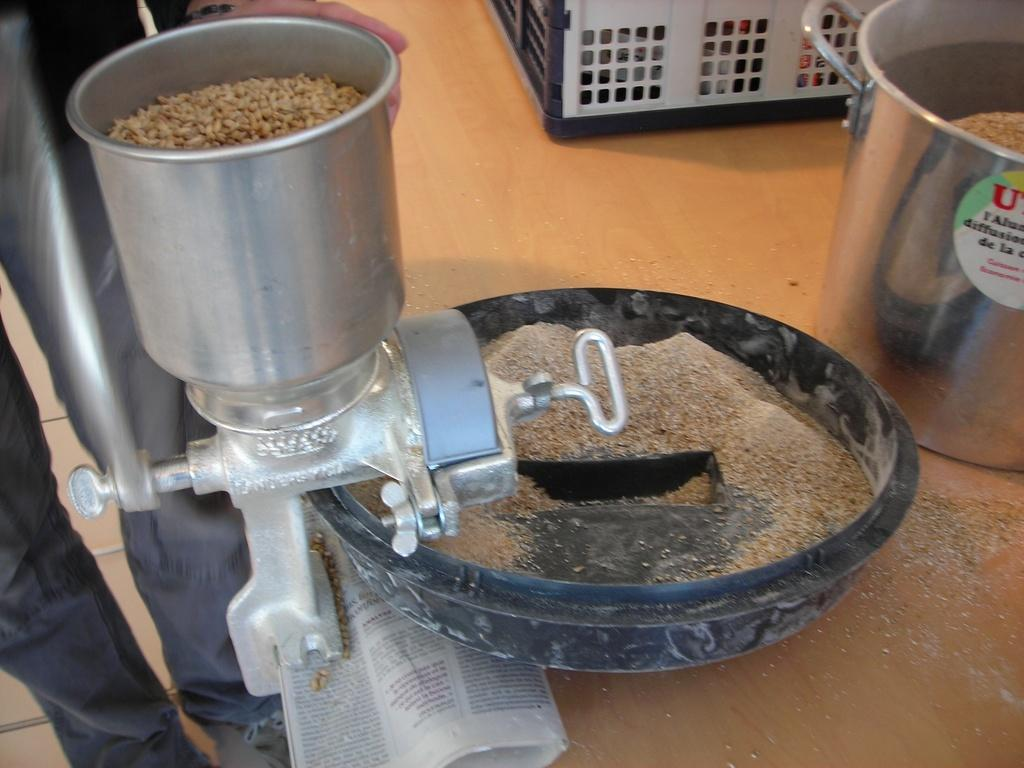What is the main object in the image? There is a grinding machine in the image. What is the grinding machine doing? The grinding machine is grinding food grains. What else can be seen in the foreground of the image? There are papers in the foreground of the image. How many parcels are being delivered by the spade in the image? There is no spade or parcel present in the image. What type of chain is being used to secure the grinding machine in the image? There is no chain present in the image; the grinding machine is not secured by any chain. 